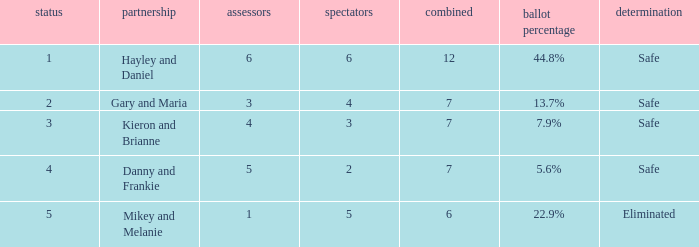How many public is there for the couple that got eliminated? 5.0. 